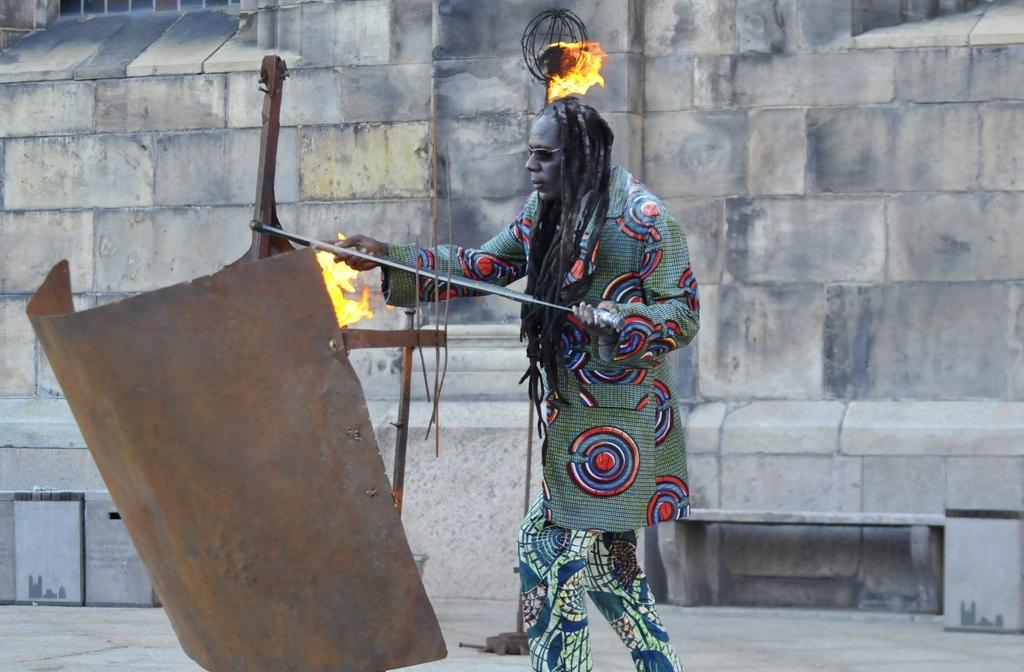What is the person in the image doing? The person is standing in the image and holding something. Can you describe the object the person is holding? Unfortunately, the specific object cannot be determined from the provided facts. What is located on the left side of the image? There is a metal sheet on the left side of the image. What can be seen in the middle of the image? There is fire in the middle of the image. What is visible in the background of the image? There is a wall in the background of the image. What time of day does the person receive approval in the image? There is no indication of time or approval in the image; it only shows a person standing, holding something, a metal sheet, fire, and a wall in the background. 